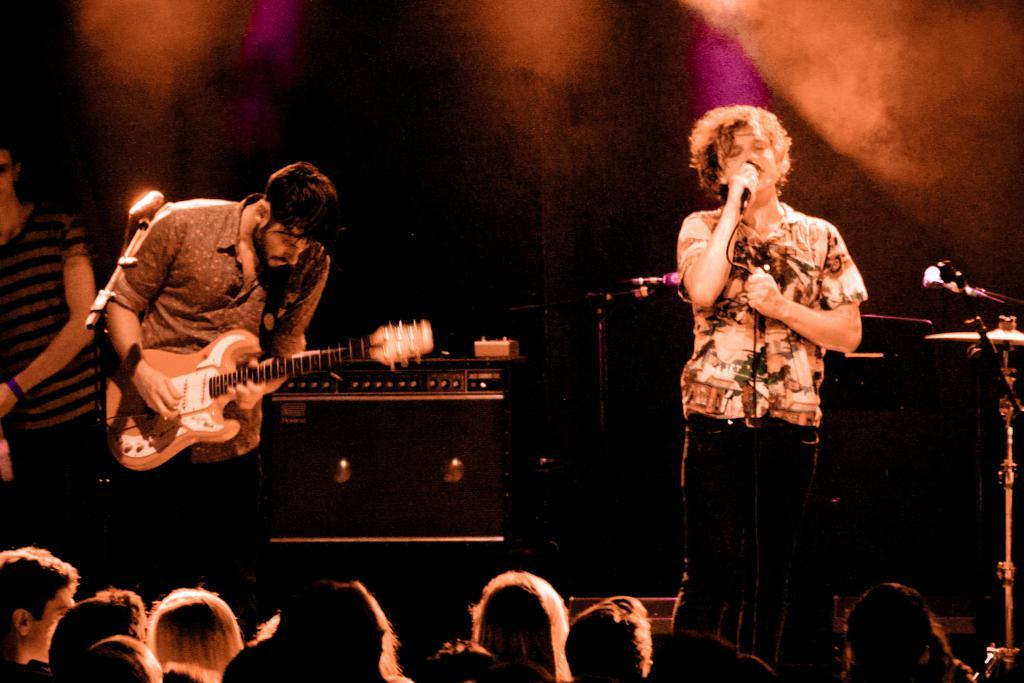What is the man in the image doing? The man is playing a guitar in the image. Who else is present in the image? There is another person in the image. What is the other person doing? The other person is singing. Can you see any windows in the image? There is no mention of a window in the provided facts, so we cannot determine if there is one present in the image. 